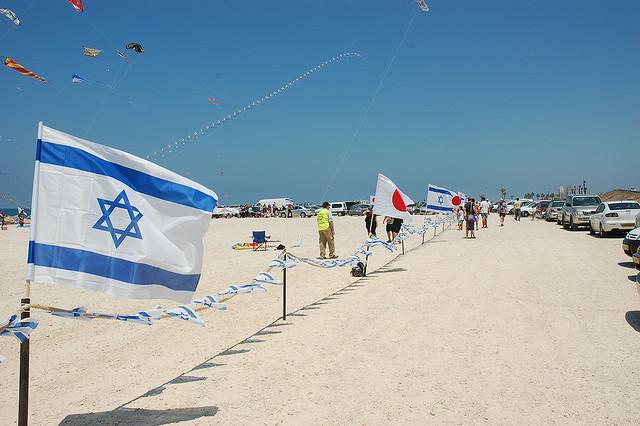What are these?
Give a very brief answer. Flags. Is this at the beach?
Short answer required. Yes. How many flags are in the picture?
Concise answer only. 4. Is the sky blue?
Keep it brief. Yes. 